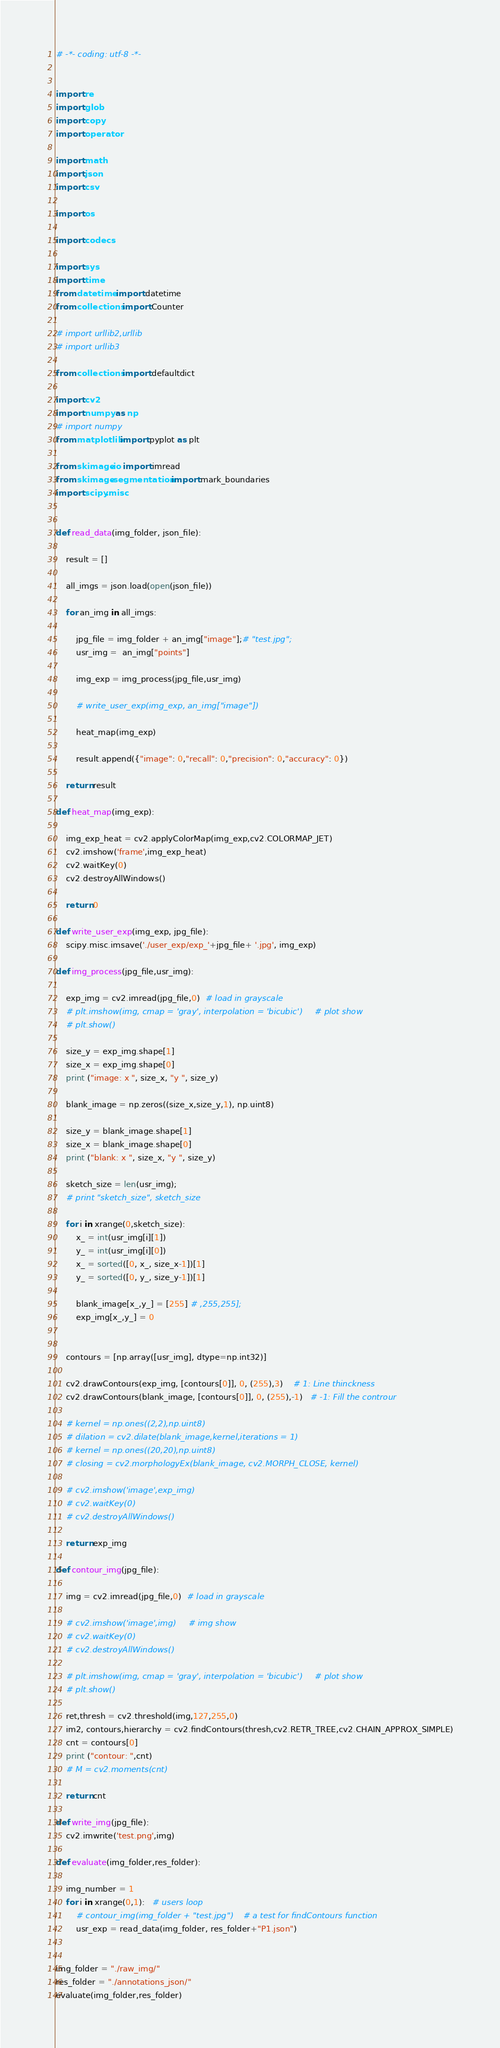<code> <loc_0><loc_0><loc_500><loc_500><_Python_># -*- coding: utf-8 -*- 


import re
import glob
import copy
import operator

import math
import json
import csv

import os

import codecs

import sys
import time
from datetime import datetime
from collections import Counter

# import urllib2,urllib
# import urllib3

from collections import defaultdict

import cv2
import numpy as np
# import numpy
from matplotlib import pyplot as plt

from skimage.io import imread
from skimage.segmentation import mark_boundaries
import scipy.misc


def read_data(img_folder, json_file):

    result = []  
    
    all_imgs = json.load(open(json_file))

    for an_img in all_imgs:

        jpg_file = img_folder + an_img["image"];# "test.jpg"; 
        usr_img =  an_img["points"]

        img_exp = img_process(jpg_file,usr_img)

        # write_user_exp(img_exp, an_img["image"])

        heat_map(img_exp)
        
        result.append({"image": 0,"recall": 0,"precision": 0,"accuracy": 0})

    return result

def heat_map(img_exp):
    
    img_exp_heat = cv2.applyColorMap(img_exp,cv2.COLORMAP_JET)
    cv2.imshow('frame',img_exp_heat)
    cv2.waitKey(0)                
    cv2.destroyAllWindows()

    return 0

def write_user_exp(img_exp, jpg_file):
    scipy.misc.imsave('./user_exp/exp_'+jpg_file+ '.jpg', img_exp)

def img_process(jpg_file,usr_img):
    
    exp_img = cv2.imread(jpg_file,0)  # load in grayscale 
    # plt.imshow(img, cmap = 'gray', interpolation = 'bicubic')     # plot show
    # plt.show()

    size_y = exp_img.shape[1] 
    size_x = exp_img.shape[0]     
    print ("image: x ", size_x, "y ", size_y)
    
    blank_image = np.zeros((size_x,size_y,1), np.uint8)

    size_y = blank_image.shape[1] 
    size_x = blank_image.shape[0]     
    print ("blank: x ", size_x, "y ", size_y)

    sketch_size = len(usr_img);
    # print "sketch_size", sketch_size

    for i in xrange(0,sketch_size):
        x_ = int(usr_img[i][1])
        y_ = int(usr_img[i][0])
        x_ = sorted([0, x_, size_x-1])[1]
        y_ = sorted([0, y_, size_y-1])[1]

        blank_image[x_,y_] = [255] # ,255,255];
        exp_img[x_,y_] = 0
    

    contours = [np.array([usr_img], dtype=np.int32)]
    
    cv2.drawContours(exp_img, [contours[0]], 0, (255),3)    # 1: Line thinckness 
    cv2.drawContours(blank_image, [contours[0]], 0, (255),-1)   # -1: Fill the controur 
    
    # kernel = np.ones((2,2),np.uint8)
    # dilation = cv2.dilate(blank_image,kernel,iterations = 1)
    # kernel = np.ones((20,20),np.uint8)
    # closing = cv2.morphologyEx(blank_image, cv2.MORPH_CLOSE, kernel)

    # cv2.imshow('image',exp_img)   
    # cv2.waitKey(0)                
    # cv2.destroyAllWindows()

    return exp_img

def contour_img(jpg_file):
    
    img = cv2.imread(jpg_file,0)  # load in grayscale 
    
    # cv2.imshow('image',img)     # img show
    # cv2.waitKey(0)                
    # cv2.destroyAllWindows()

    # plt.imshow(img, cmap = 'gray', interpolation = 'bicubic')     # plot show
    # plt.show()

    ret,thresh = cv2.threshold(img,127,255,0)   
    im2, contours,hierarchy = cv2.findContours(thresh,cv2.RETR_TREE,cv2.CHAIN_APPROX_SIMPLE)
    cnt = contours[0]  
    print ("contour: ",cnt)
    # M = cv2.moments(cnt)

    return cnt

def write_img(jpg_file):
    cv2.imwrite('test.png',img)

def evaluate(img_folder,res_folder):

    img_number = 1
    for i in xrange(0,1):   # users loop 
        # contour_img(img_folder + "test.jpg")    # a test for findContours function 
        usr_exp = read_data(img_folder, res_folder+"P1.json")


img_folder = "./raw_img/"
res_folder = "./annotations_json/"
evaluate(img_folder,res_folder)
</code> 